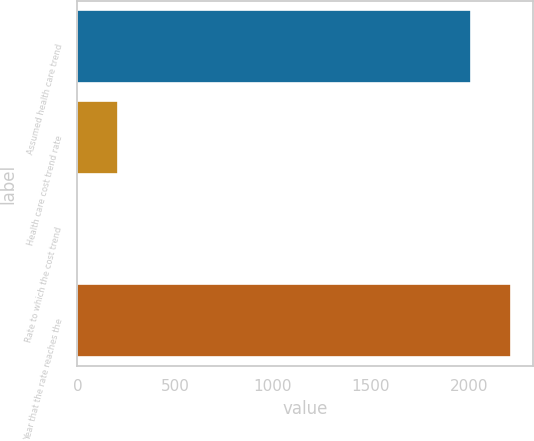<chart> <loc_0><loc_0><loc_500><loc_500><bar_chart><fcel>Assumed health care trend<fcel>Health care cost trend rate<fcel>Rate to which the cost trend<fcel>Year that the rate reaches the<nl><fcel>2014<fcel>206.4<fcel>4.55<fcel>2215.85<nl></chart> 